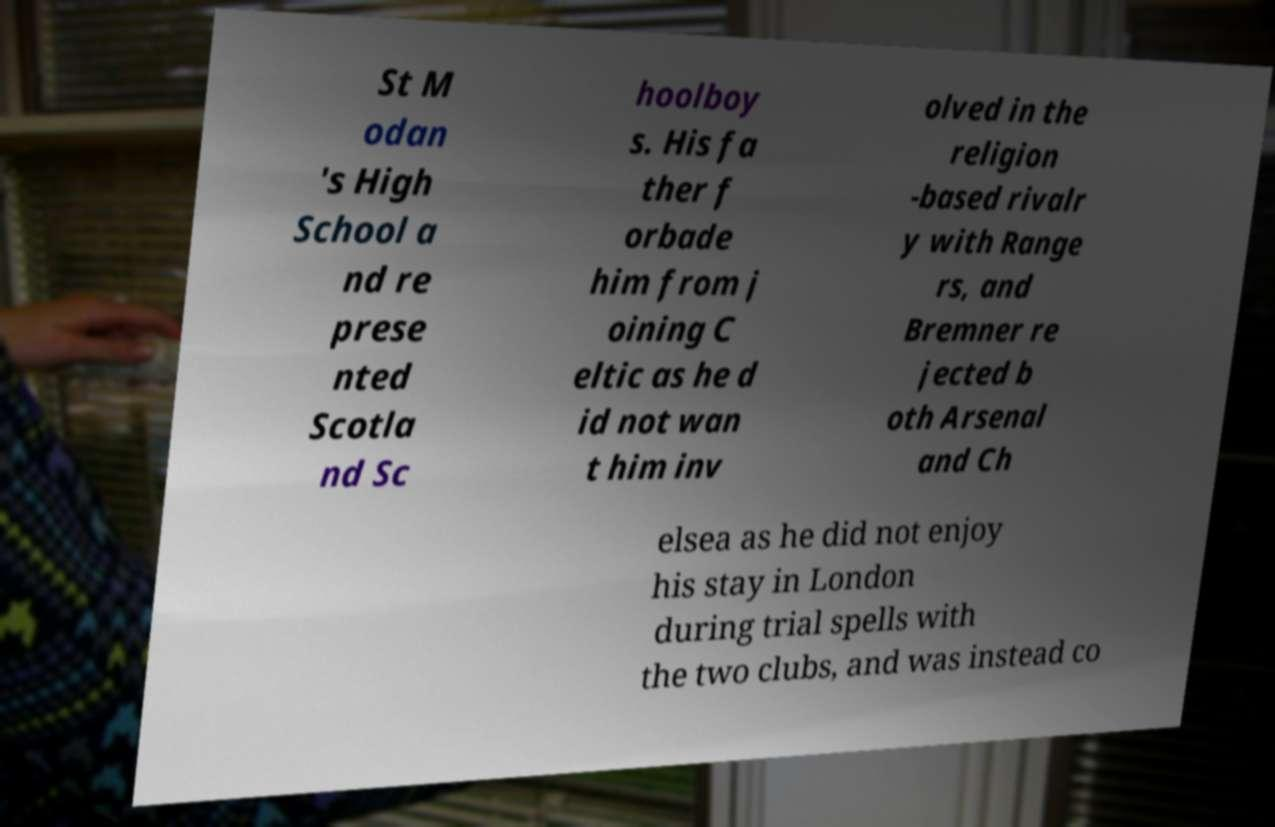There's text embedded in this image that I need extracted. Can you transcribe it verbatim? St M odan 's High School a nd re prese nted Scotla nd Sc hoolboy s. His fa ther f orbade him from j oining C eltic as he d id not wan t him inv olved in the religion -based rivalr y with Range rs, and Bremner re jected b oth Arsenal and Ch elsea as he did not enjoy his stay in London during trial spells with the two clubs, and was instead co 